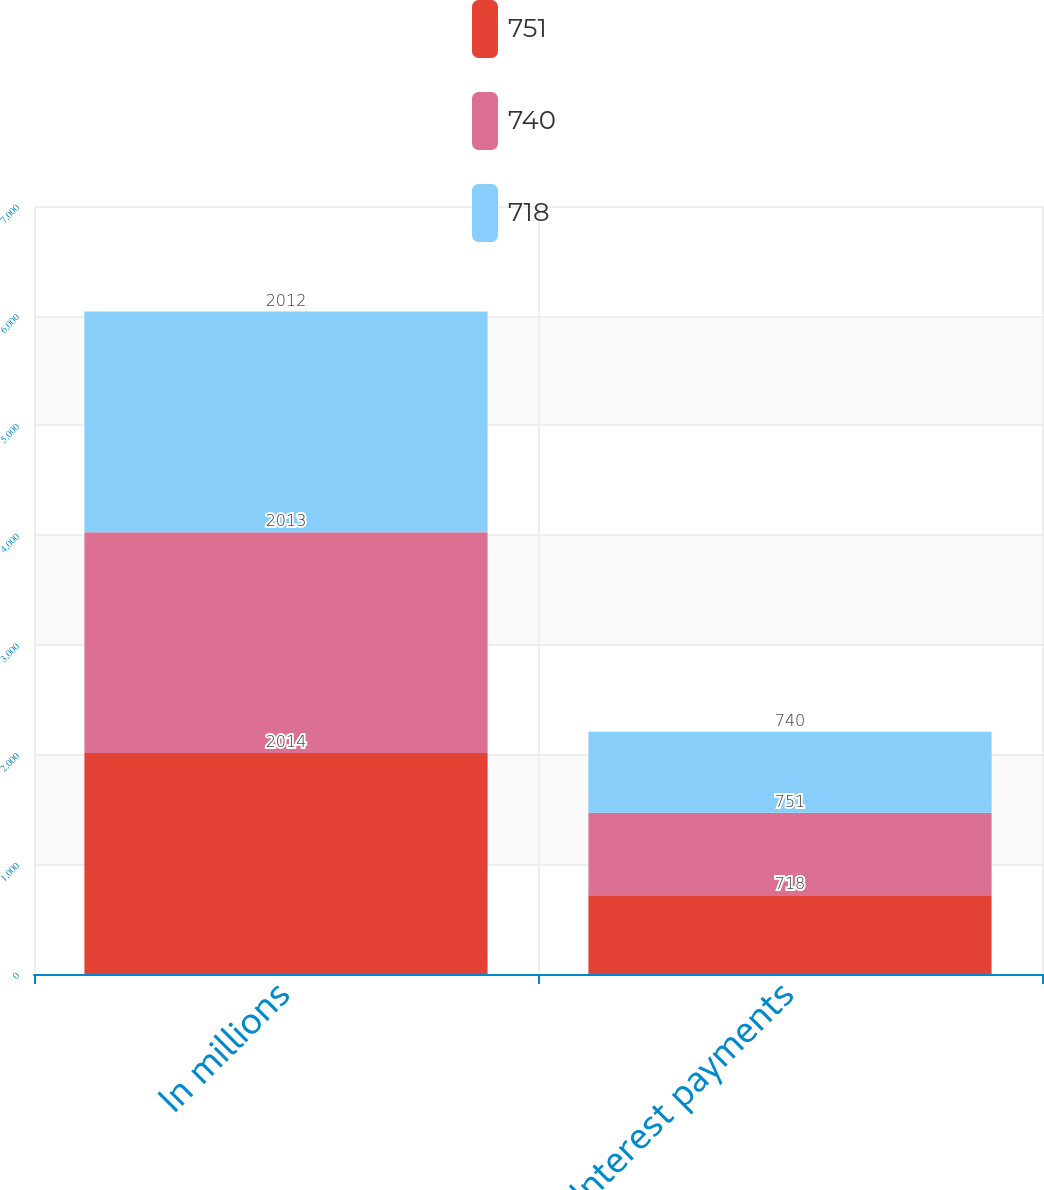Convert chart. <chart><loc_0><loc_0><loc_500><loc_500><stacked_bar_chart><ecel><fcel>In millions<fcel>Interest payments<nl><fcel>751<fcel>2014<fcel>718<nl><fcel>740<fcel>2013<fcel>751<nl><fcel>718<fcel>2012<fcel>740<nl></chart> 